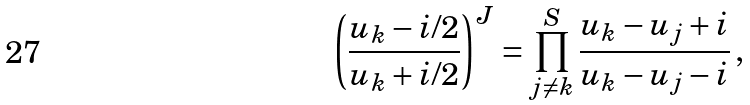<formula> <loc_0><loc_0><loc_500><loc_500>\left ( \frac { u _ { k } - i / 2 } { u _ { k } + i / 2 } \right ) ^ { J } = \prod ^ { S } _ { j \neq k } \frac { u _ { k } - u _ { j } + i } { u _ { k } - u _ { j } - i } \, ,</formula> 